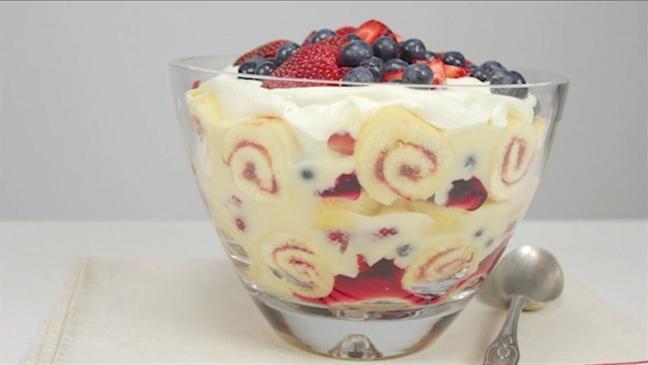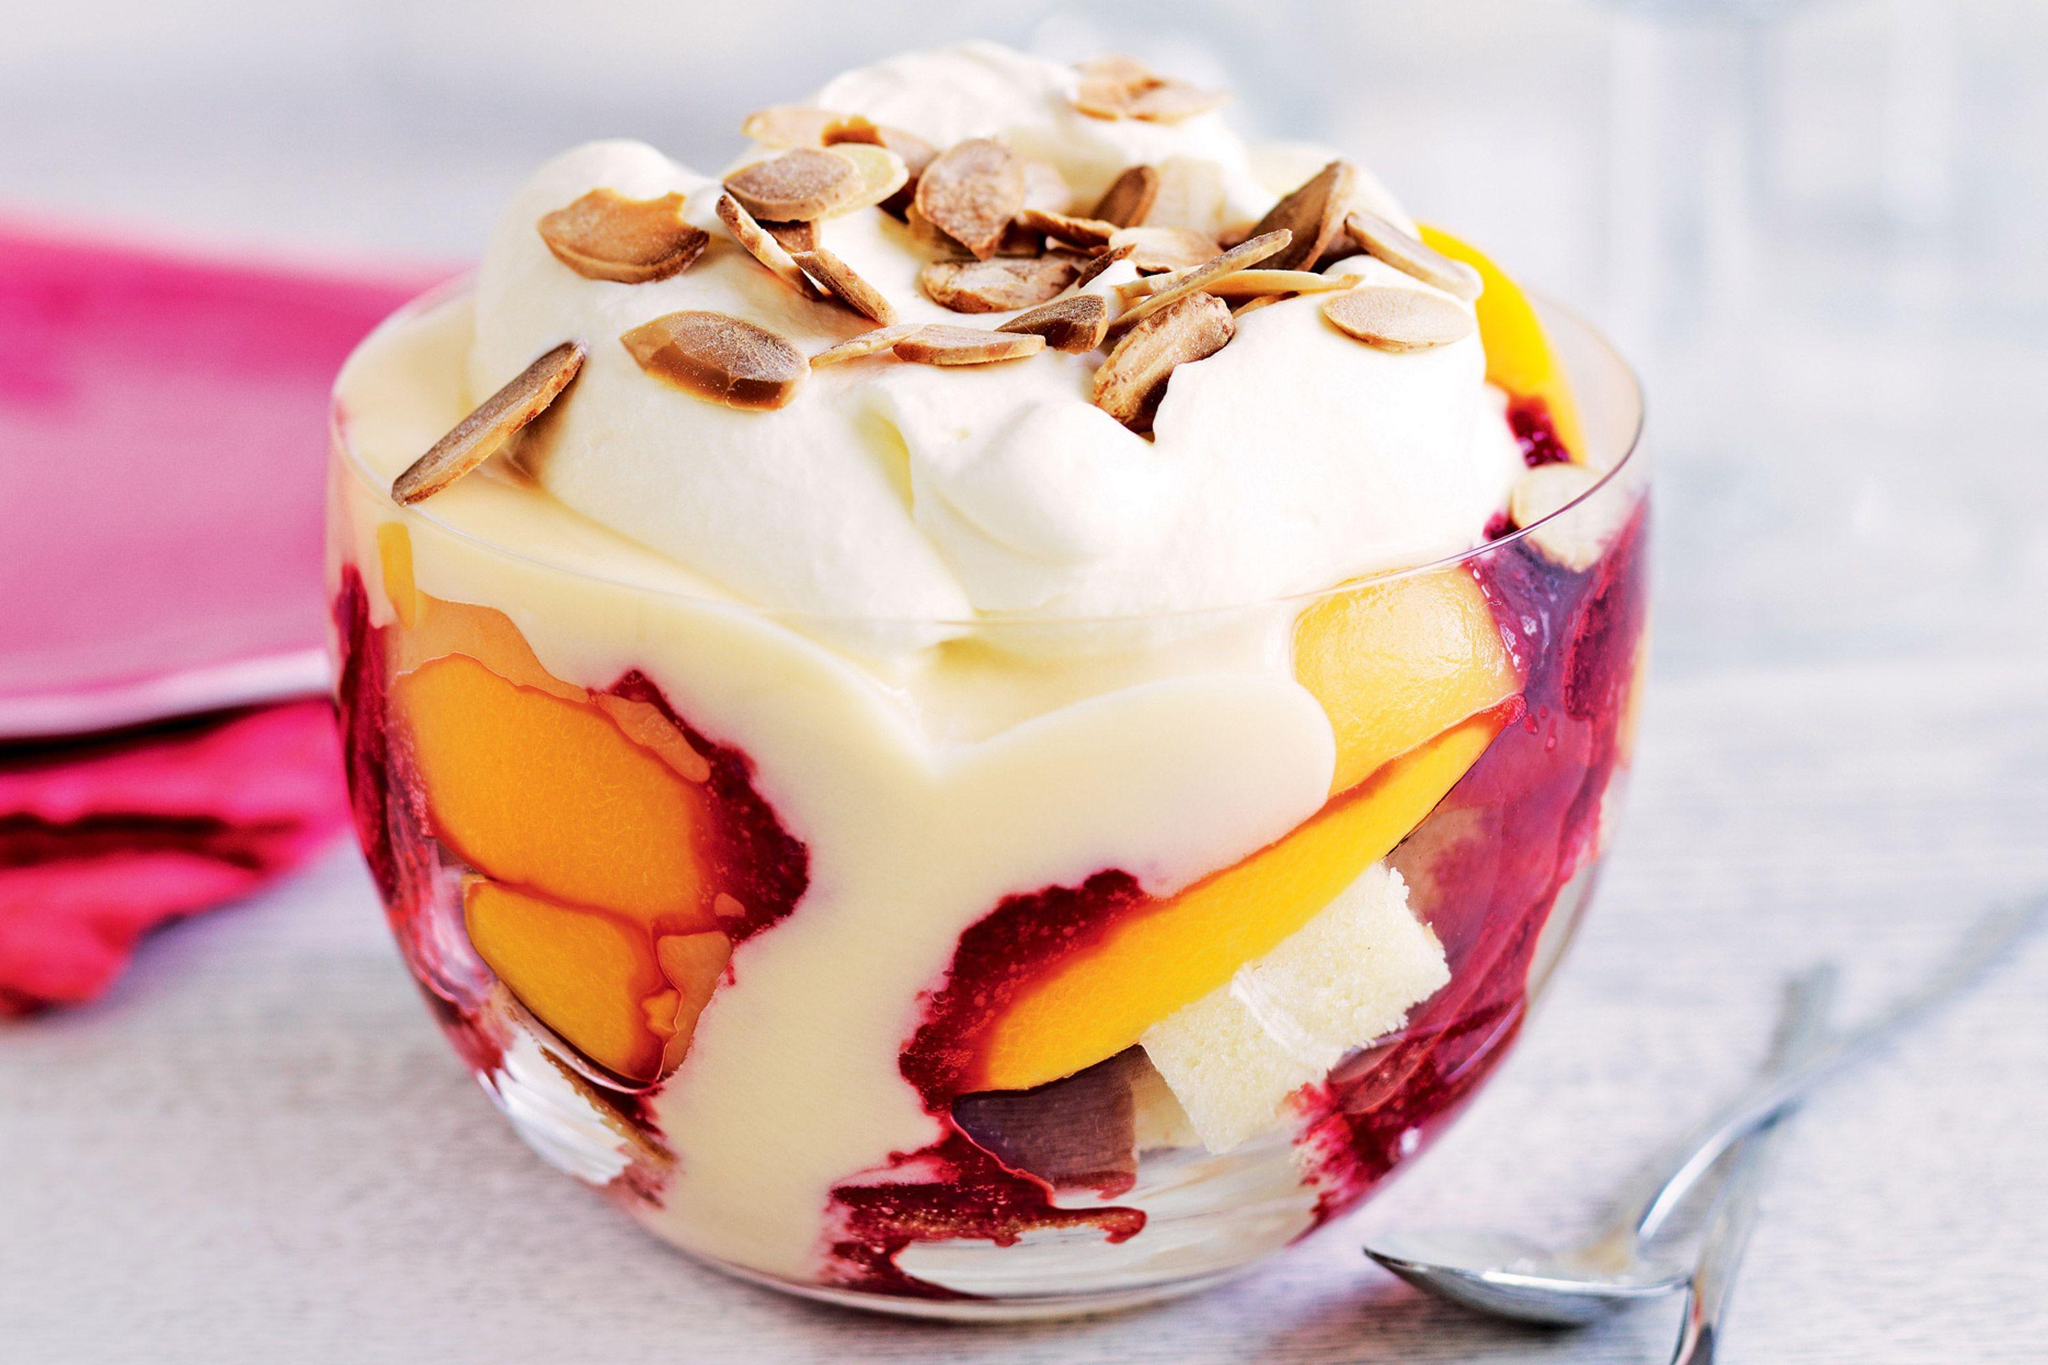The first image is the image on the left, the second image is the image on the right. Given the left and right images, does the statement "An image shows just one dessert bowl, topped with blueberries and strawberries." hold true? Answer yes or no. Yes. 